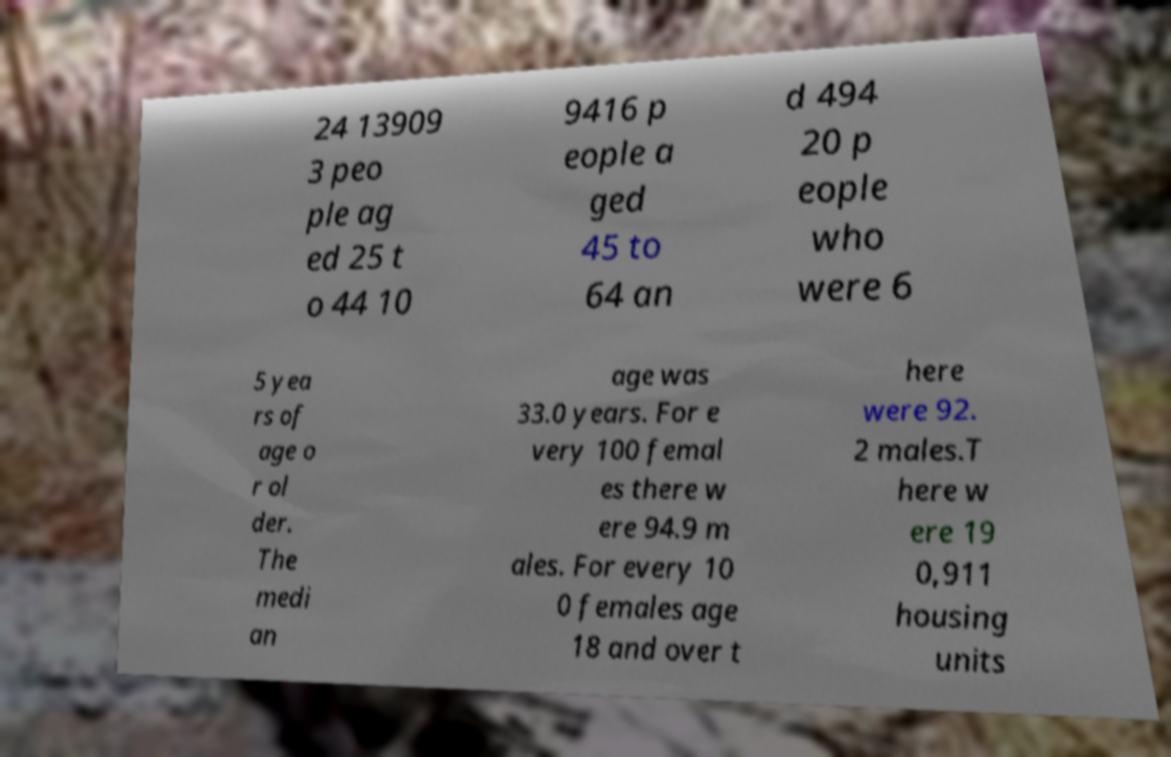Can you read and provide the text displayed in the image?This photo seems to have some interesting text. Can you extract and type it out for me? 24 13909 3 peo ple ag ed 25 t o 44 10 9416 p eople a ged 45 to 64 an d 494 20 p eople who were 6 5 yea rs of age o r ol der. The medi an age was 33.0 years. For e very 100 femal es there w ere 94.9 m ales. For every 10 0 females age 18 and over t here were 92. 2 males.T here w ere 19 0,911 housing units 